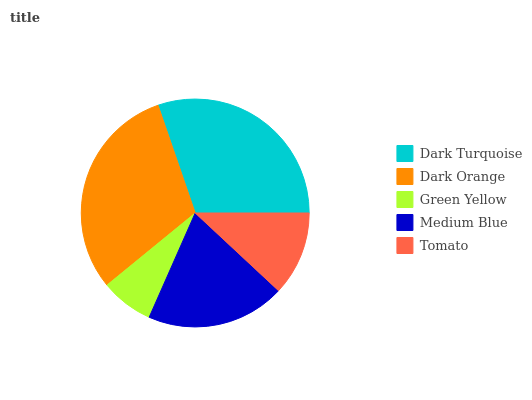Is Green Yellow the minimum?
Answer yes or no. Yes. Is Dark Orange the maximum?
Answer yes or no. Yes. Is Dark Orange the minimum?
Answer yes or no. No. Is Green Yellow the maximum?
Answer yes or no. No. Is Dark Orange greater than Green Yellow?
Answer yes or no. Yes. Is Green Yellow less than Dark Orange?
Answer yes or no. Yes. Is Green Yellow greater than Dark Orange?
Answer yes or no. No. Is Dark Orange less than Green Yellow?
Answer yes or no. No. Is Medium Blue the high median?
Answer yes or no. Yes. Is Medium Blue the low median?
Answer yes or no. Yes. Is Dark Turquoise the high median?
Answer yes or no. No. Is Green Yellow the low median?
Answer yes or no. No. 